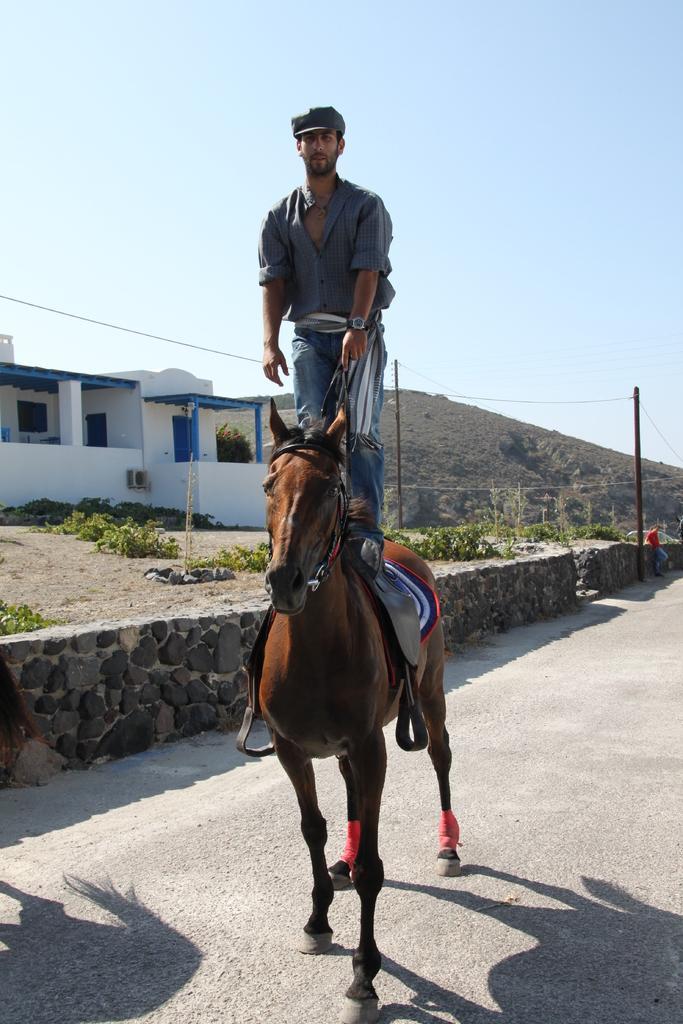How would you summarize this image in a sentence or two? In the image we can see a man wearing clothes, a cap, a wristwatch and the man is standing on the horse. Here we can see the road, wall and grass. Here we can see the house, electric wire, hill and the sky. 